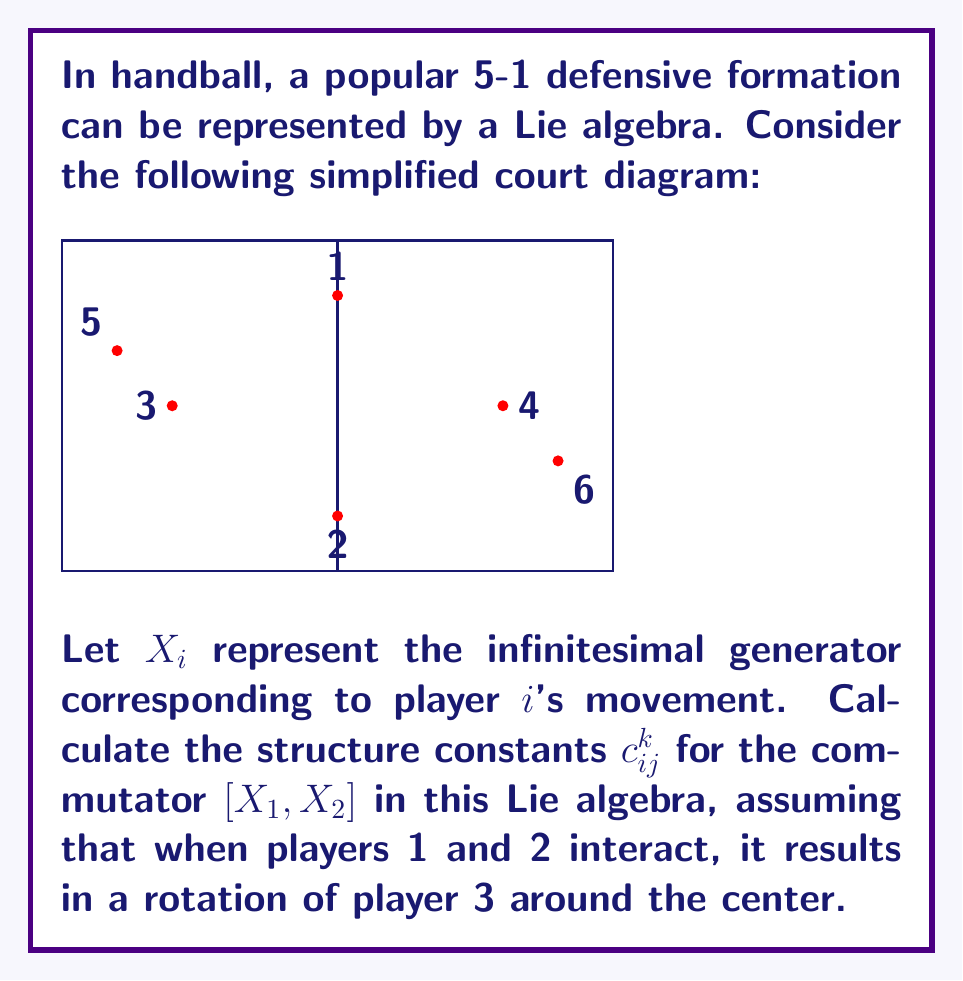Give your solution to this math problem. To solve this problem, we need to follow these steps:

1) In a Lie algebra, the commutator $[X_i, X_j]$ can be expressed as a linear combination of the basis elements:

   $$[X_i, X_j] = \sum_{k=1}^6 c_{ij}^k X_k$$

   where $c_{ij}^k$ are the structure constants.

2) Given that the interaction of players 1 and 2 results in a rotation of player 3, we can assume that:

   $$[X_1, X_2] = c_{12}^3 X_3$$

   All other structure constants $c_{12}^k$ for $k \neq 3$ are zero.

3) To determine $c_{12}^3$, we need to consider the geometry of the court and the nature of the rotation:

   - Players 1 and 2 are at opposite ends of the center line.
   - Player 3 is positioned at (-3,0) in our coordinate system.
   - A full rotation would move player 3 in a circle of radius 3 around the center.

4) In Lie algebra theory, the magnitude of the structure constant often corresponds to the strength of the interaction. Here, we can relate it to the angle of rotation.

5) For a standard rotation, we might use $2\pi$ (full rotation) or $\pi/2$ (quarter rotation). Given the strategic nature of handball, let's assume a quarter rotation is more realistic.

6) Therefore, we can set:

   $$c_{12}^3 = \frac{\pi}{2}$$

This value ensures that the commutator $[X_1, X_2]$ generates a quarter rotation of player 3 around the center of the court.
Answer: $c_{12}^3 = \frac{\pi}{2}$, all other $c_{12}^k = 0$ 